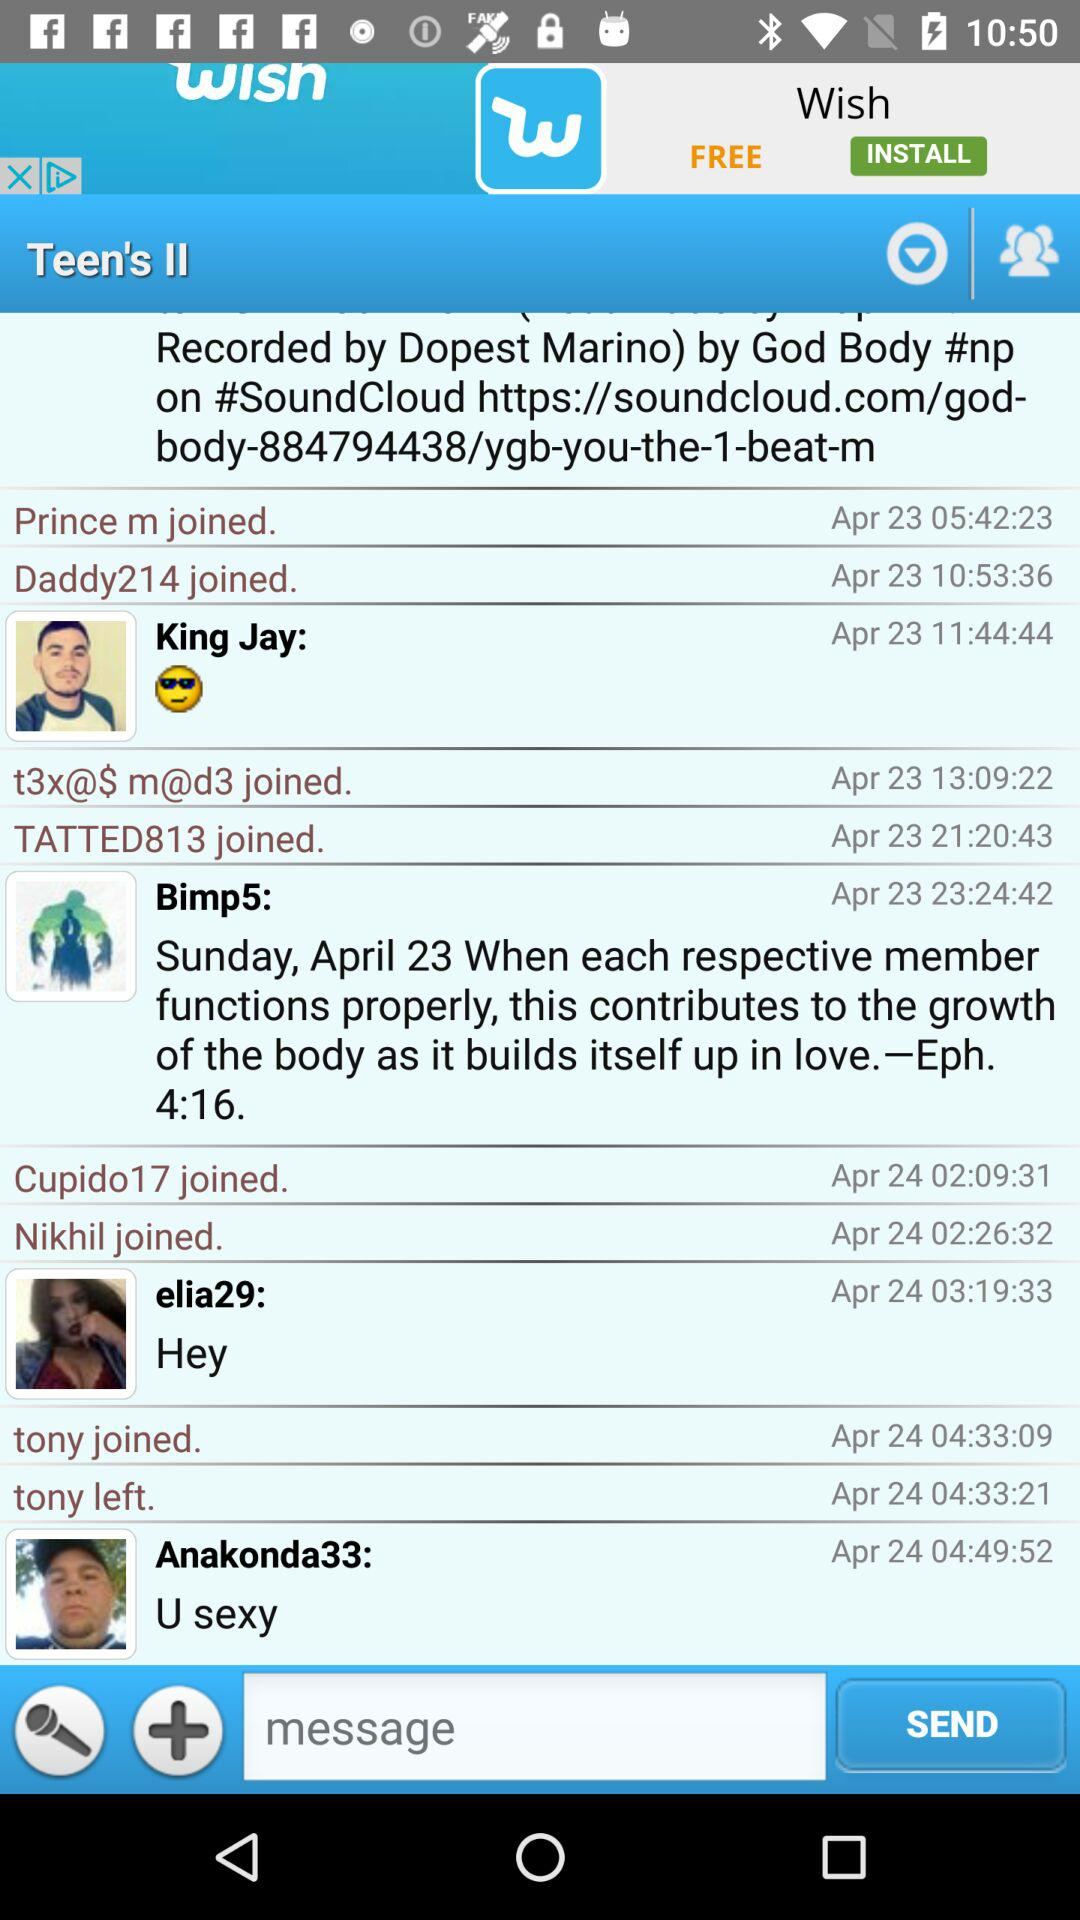At what time and date was "Cupido17" joined? "Cupido17" was joined on April 24 at 02:09:31. 